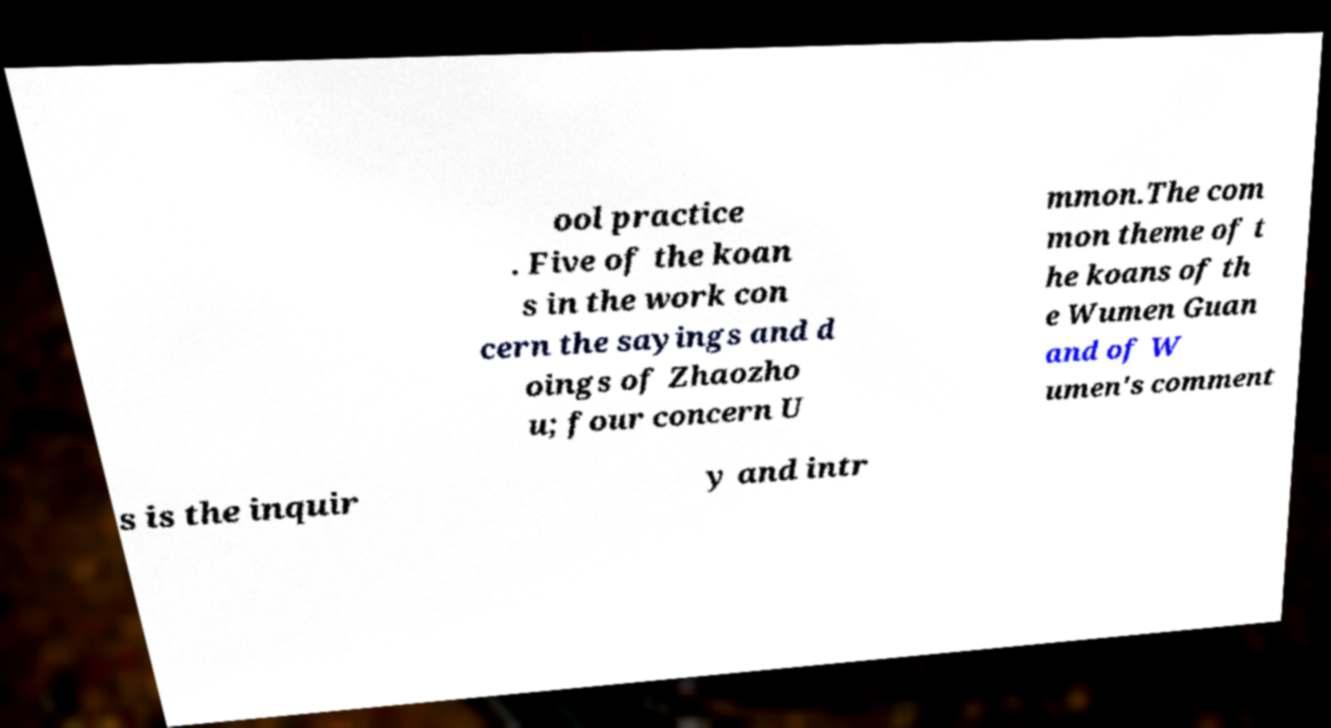For documentation purposes, I need the text within this image transcribed. Could you provide that? ool practice . Five of the koan s in the work con cern the sayings and d oings of Zhaozho u; four concern U mmon.The com mon theme of t he koans of th e Wumen Guan and of W umen's comment s is the inquir y and intr 